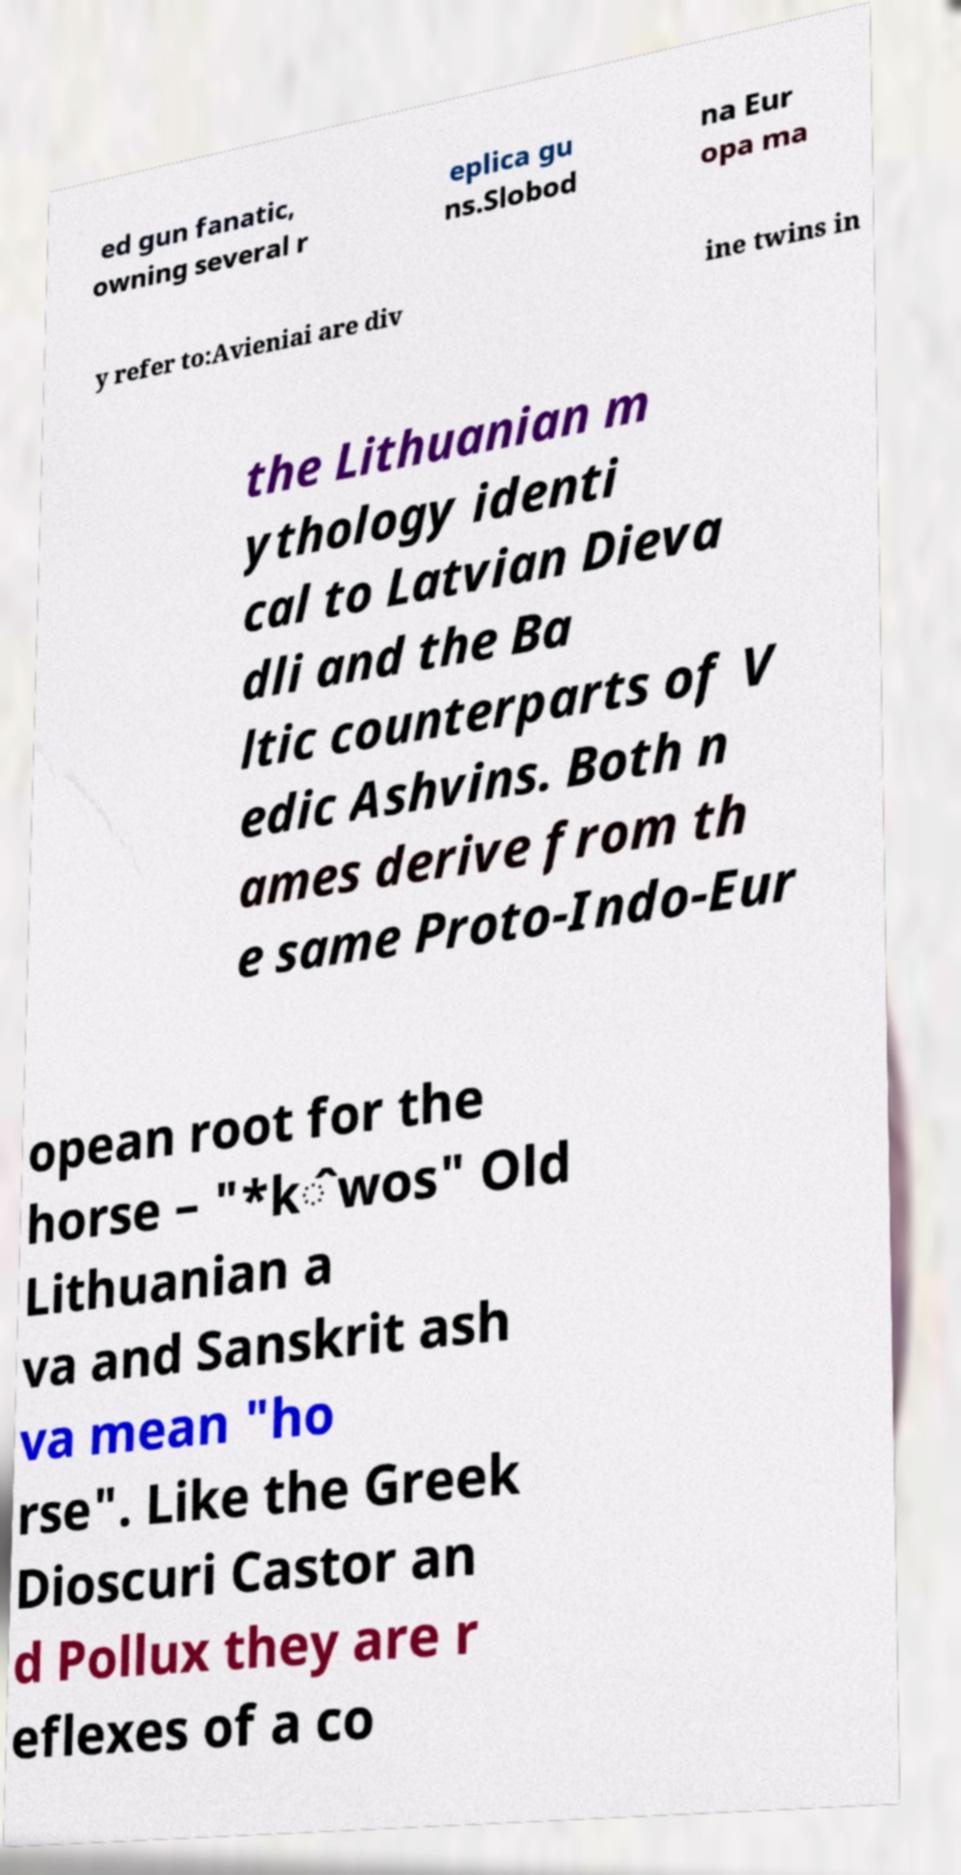Could you extract and type out the text from this image? ed gun fanatic, owning several r eplica gu ns.Slobod na Eur opa ma y refer to:Avieniai are div ine twins in the Lithuanian m ythology identi cal to Latvian Dieva dli and the Ba ltic counterparts of V edic Ashvins. Both n ames derive from th e same Proto-Indo-Eur opean root for the horse – "*k̂wos" Old Lithuanian a va and Sanskrit ash va mean "ho rse". Like the Greek Dioscuri Castor an d Pollux they are r eflexes of a co 